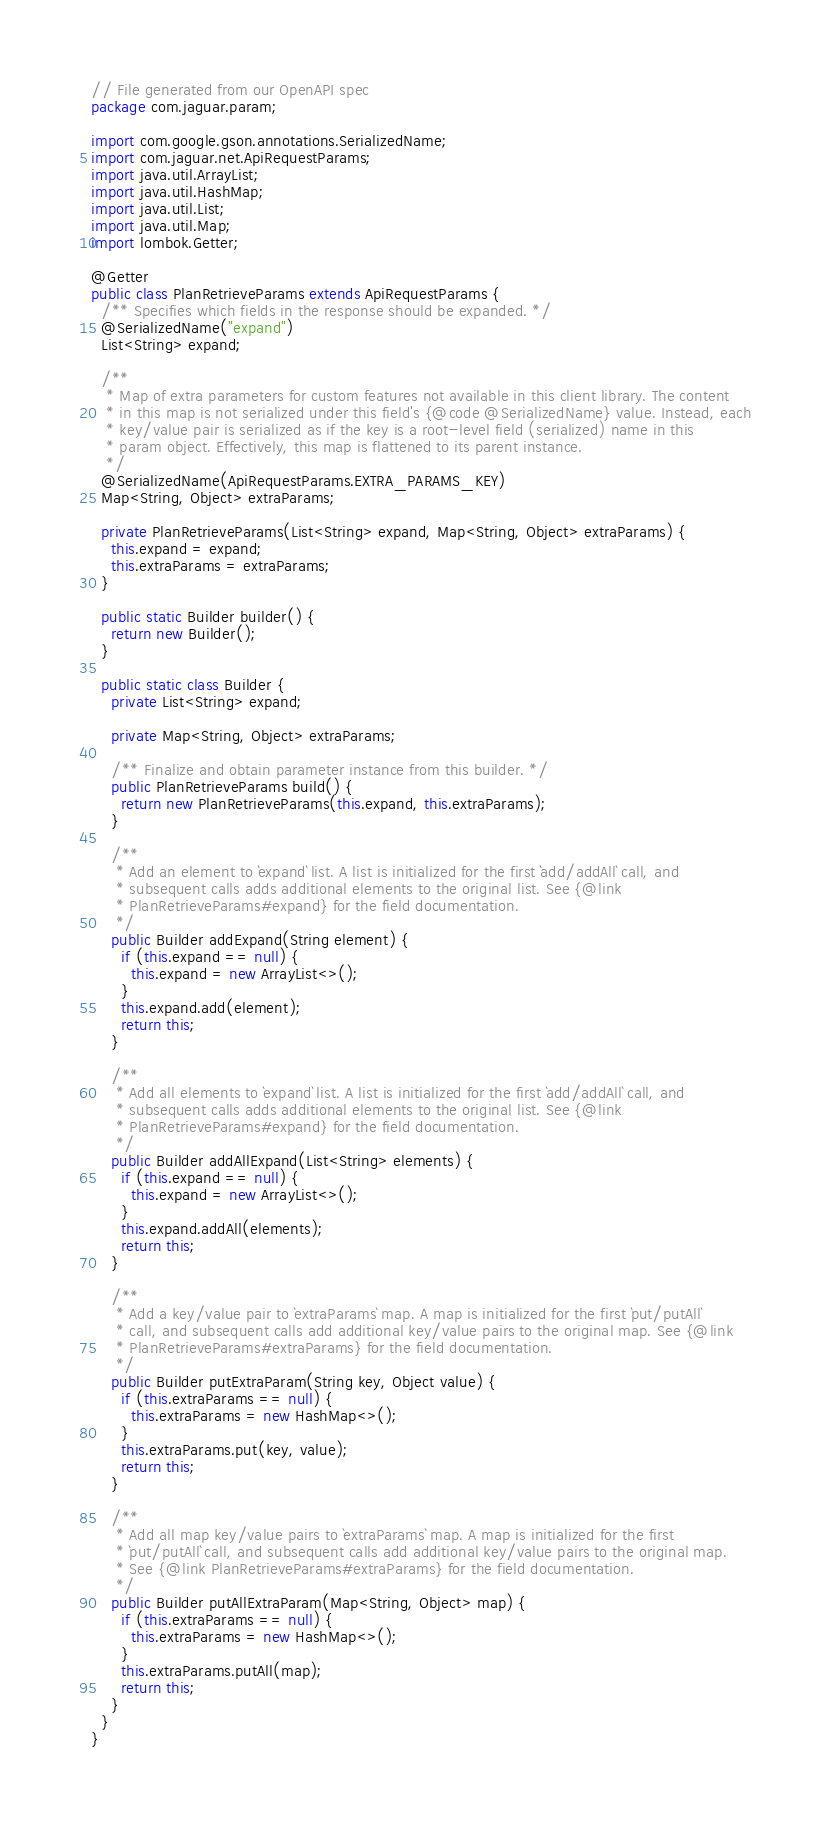<code> <loc_0><loc_0><loc_500><loc_500><_Java_>// File generated from our OpenAPI spec
package com.jaguar.param;

import com.google.gson.annotations.SerializedName;
import com.jaguar.net.ApiRequestParams;
import java.util.ArrayList;
import java.util.HashMap;
import java.util.List;
import java.util.Map;
import lombok.Getter;

@Getter
public class PlanRetrieveParams extends ApiRequestParams {
  /** Specifies which fields in the response should be expanded. */
  @SerializedName("expand")
  List<String> expand;

  /**
   * Map of extra parameters for custom features not available in this client library. The content
   * in this map is not serialized under this field's {@code @SerializedName} value. Instead, each
   * key/value pair is serialized as if the key is a root-level field (serialized) name in this
   * param object. Effectively, this map is flattened to its parent instance.
   */
  @SerializedName(ApiRequestParams.EXTRA_PARAMS_KEY)
  Map<String, Object> extraParams;

  private PlanRetrieveParams(List<String> expand, Map<String, Object> extraParams) {
    this.expand = expand;
    this.extraParams = extraParams;
  }

  public static Builder builder() {
    return new Builder();
  }

  public static class Builder {
    private List<String> expand;

    private Map<String, Object> extraParams;

    /** Finalize and obtain parameter instance from this builder. */
    public PlanRetrieveParams build() {
      return new PlanRetrieveParams(this.expand, this.extraParams);
    }

    /**
     * Add an element to `expand` list. A list is initialized for the first `add/addAll` call, and
     * subsequent calls adds additional elements to the original list. See {@link
     * PlanRetrieveParams#expand} for the field documentation.
     */
    public Builder addExpand(String element) {
      if (this.expand == null) {
        this.expand = new ArrayList<>();
      }
      this.expand.add(element);
      return this;
    }

    /**
     * Add all elements to `expand` list. A list is initialized for the first `add/addAll` call, and
     * subsequent calls adds additional elements to the original list. See {@link
     * PlanRetrieveParams#expand} for the field documentation.
     */
    public Builder addAllExpand(List<String> elements) {
      if (this.expand == null) {
        this.expand = new ArrayList<>();
      }
      this.expand.addAll(elements);
      return this;
    }

    /**
     * Add a key/value pair to `extraParams` map. A map is initialized for the first `put/putAll`
     * call, and subsequent calls add additional key/value pairs to the original map. See {@link
     * PlanRetrieveParams#extraParams} for the field documentation.
     */
    public Builder putExtraParam(String key, Object value) {
      if (this.extraParams == null) {
        this.extraParams = new HashMap<>();
      }
      this.extraParams.put(key, value);
      return this;
    }

    /**
     * Add all map key/value pairs to `extraParams` map. A map is initialized for the first
     * `put/putAll` call, and subsequent calls add additional key/value pairs to the original map.
     * See {@link PlanRetrieveParams#extraParams} for the field documentation.
     */
    public Builder putAllExtraParam(Map<String, Object> map) {
      if (this.extraParams == null) {
        this.extraParams = new HashMap<>();
      }
      this.extraParams.putAll(map);
      return this;
    }
  }
}
</code> 